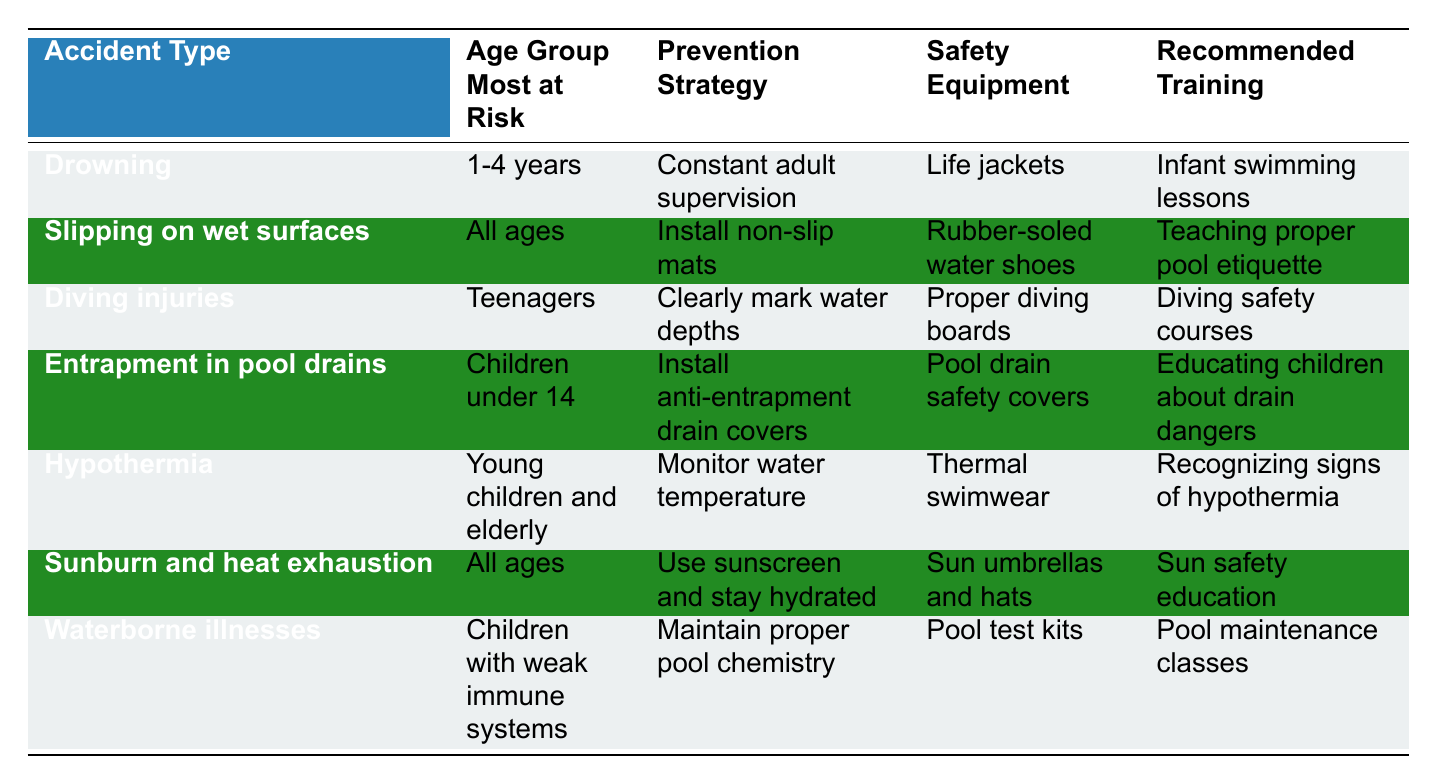What age group is most at risk for drowning? The table specifically states that the age group most at risk for drowning is "1-4 years."
Answer: 1-4 years What prevention strategy is recommended for slipping on wet surfaces? The table indicates that the prevention strategy for slipping on wet surfaces is to "Install non-slip mats."
Answer: Install non-slip mats Is it true that all age groups are at risk for sunburn and heat exhaustion? The table lists "All ages" as the age group most at risk for sunburn and heat exhaustion, confirming that it is true.
Answer: Yes What specific safety equipment is recommended for preventing entrapment in pool drains? According to the table, the safety equipment recommended to prevent entrapment in pool drains is "Pool drain safety covers."
Answer: Pool drain safety covers How many recommended training options are there for waterborne illnesses? The table shows one recommended training option for waterborne illnesses, which is "Pool maintenance classes."
Answer: 1 What is the prevention strategy for hypothermia related to monitoring water temperature? The prevention strategy for hypothermia related to monitoring water temperature is to "Monitor water temperature."
Answer: Monitor water temperature Which accident type has the highest risk age group being under 14 years old? The accident type that has the highest risk age group being under 14 years old is "Entrapment in pool drains."
Answer: Entrapment in pool drains What do the safety equipment recommendations suggest for drowning prevention? The recommendation for drowning prevention states to use "Life jackets" as safety equipment.
Answer: Life jackets If we compare drowning and slipping on wet surfaces, what is the common prevention strategy? Analyzing both, we see that the prevention strategy for drowning is "Constant adult supervision," while for slipping it’s "Install non-slip mats," showing they are different. So, there’s no common strategy.
Answer: None What are the recommended training options for teenagers regarding diving injuries? The table specifies that the recommended training option for teenagers concerning diving injuries is "Diving safety courses."
Answer: Diving safety courses 